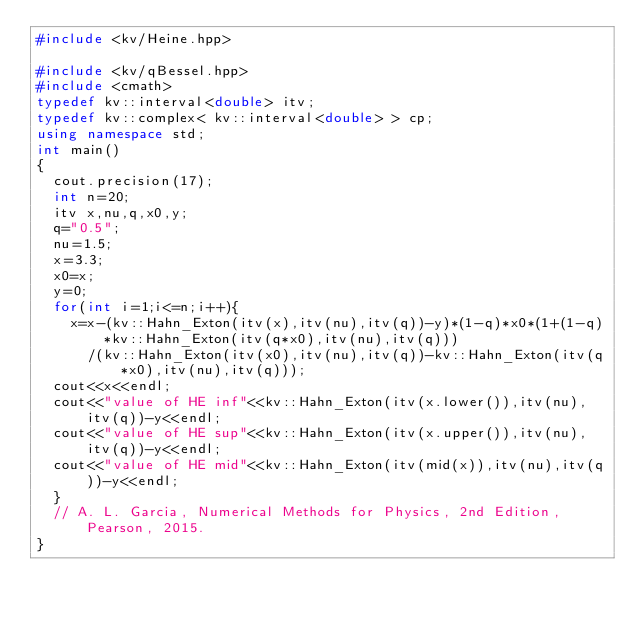Convert code to text. <code><loc_0><loc_0><loc_500><loc_500><_C++_>#include <kv/Heine.hpp>

#include <kv/qBessel.hpp>
#include <cmath>
typedef kv::interval<double> itv;
typedef kv::complex< kv::interval<double> > cp;
using namespace std;
int main()
{
  cout.precision(17);
  int n=20;
  itv x,nu,q,x0,y;
  q="0.5";
  nu=1.5;
  x=3.3;
  x0=x;
  y=0;
  for(int i=1;i<=n;i++){
    x=x-(kv::Hahn_Exton(itv(x),itv(nu),itv(q))-y)*(1-q)*x0*(1+(1-q)*kv::Hahn_Exton(itv(q*x0),itv(nu),itv(q)))
      /(kv::Hahn_Exton(itv(x0),itv(nu),itv(q))-kv::Hahn_Exton(itv(q*x0),itv(nu),itv(q)));
  cout<<x<<endl;
  cout<<"value of HE inf"<<kv::Hahn_Exton(itv(x.lower()),itv(nu),itv(q))-y<<endl;
  cout<<"value of HE sup"<<kv::Hahn_Exton(itv(x.upper()),itv(nu),itv(q))-y<<endl;
  cout<<"value of HE mid"<<kv::Hahn_Exton(itv(mid(x)),itv(nu),itv(q))-y<<endl;
  }
  // A. L. Garcia, Numerical Methods for Physics, 2nd Edition, Pearson, 2015.
}

</code> 